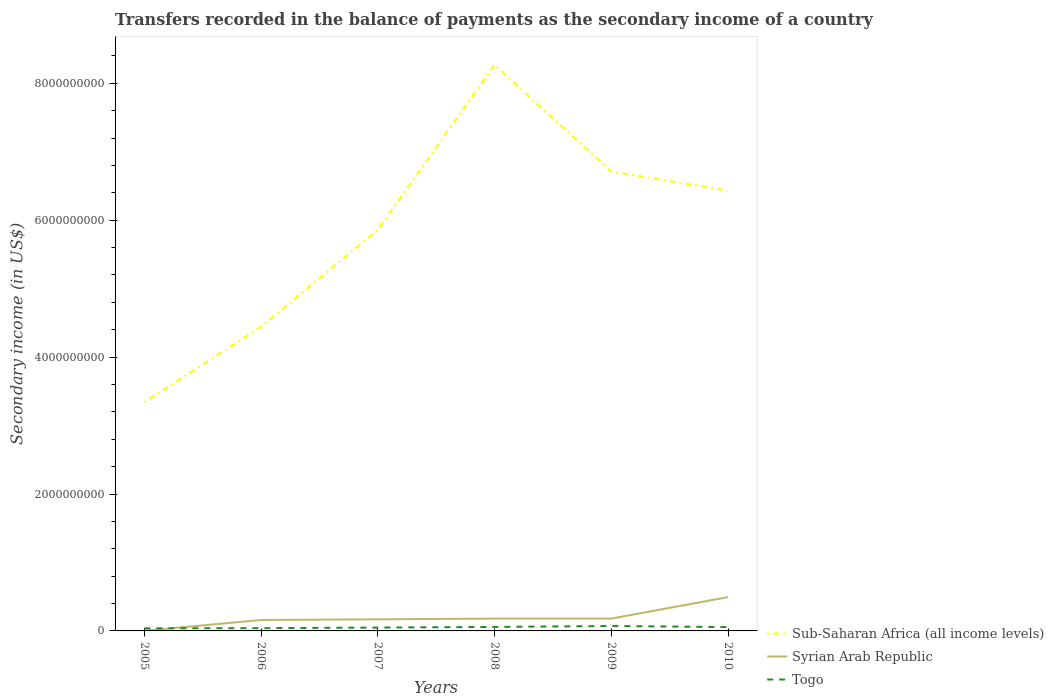How many different coloured lines are there?
Offer a very short reply. 3. Does the line corresponding to Sub-Saharan Africa (all income levels) intersect with the line corresponding to Togo?
Give a very brief answer. No. Across all years, what is the maximum secondary income of in Togo?
Keep it short and to the point. 3.81e+07. What is the total secondary income of in Togo in the graph?
Offer a very short reply. -2.27e+07. What is the difference between the highest and the second highest secondary income of in Sub-Saharan Africa (all income levels)?
Keep it short and to the point. 4.93e+09. Is the secondary income of in Syrian Arab Republic strictly greater than the secondary income of in Sub-Saharan Africa (all income levels) over the years?
Offer a terse response. Yes. How many lines are there?
Your response must be concise. 3. What is the difference between two consecutive major ticks on the Y-axis?
Provide a short and direct response. 2.00e+09. Does the graph contain grids?
Keep it short and to the point. No. Where does the legend appear in the graph?
Keep it short and to the point. Bottom right. How many legend labels are there?
Provide a short and direct response. 3. What is the title of the graph?
Provide a short and direct response. Transfers recorded in the balance of payments as the secondary income of a country. Does "Aruba" appear as one of the legend labels in the graph?
Provide a short and direct response. No. What is the label or title of the X-axis?
Your answer should be compact. Years. What is the label or title of the Y-axis?
Your response must be concise. Secondary income (in US$). What is the Secondary income (in US$) of Sub-Saharan Africa (all income levels) in 2005?
Offer a terse response. 3.34e+09. What is the Secondary income (in US$) of Togo in 2005?
Ensure brevity in your answer.  3.81e+07. What is the Secondary income (in US$) in Sub-Saharan Africa (all income levels) in 2006?
Offer a terse response. 4.45e+09. What is the Secondary income (in US$) in Syrian Arab Republic in 2006?
Ensure brevity in your answer.  1.60e+08. What is the Secondary income (in US$) of Togo in 2006?
Offer a very short reply. 4.04e+07. What is the Secondary income (in US$) in Sub-Saharan Africa (all income levels) in 2007?
Offer a terse response. 5.86e+09. What is the Secondary income (in US$) of Syrian Arab Republic in 2007?
Ensure brevity in your answer.  1.70e+08. What is the Secondary income (in US$) of Togo in 2007?
Your answer should be compact. 4.91e+07. What is the Secondary income (in US$) in Sub-Saharan Africa (all income levels) in 2008?
Provide a short and direct response. 8.27e+09. What is the Secondary income (in US$) of Syrian Arab Republic in 2008?
Ensure brevity in your answer.  1.80e+08. What is the Secondary income (in US$) of Togo in 2008?
Give a very brief answer. 5.82e+07. What is the Secondary income (in US$) in Sub-Saharan Africa (all income levels) in 2009?
Your response must be concise. 6.71e+09. What is the Secondary income (in US$) in Syrian Arab Republic in 2009?
Your answer should be very brief. 1.80e+08. What is the Secondary income (in US$) of Togo in 2009?
Your answer should be very brief. 7.19e+07. What is the Secondary income (in US$) in Sub-Saharan Africa (all income levels) in 2010?
Give a very brief answer. 6.43e+09. What is the Secondary income (in US$) in Syrian Arab Republic in 2010?
Provide a succinct answer. 4.94e+08. What is the Secondary income (in US$) in Togo in 2010?
Make the answer very short. 5.58e+07. Across all years, what is the maximum Secondary income (in US$) of Sub-Saharan Africa (all income levels)?
Give a very brief answer. 8.27e+09. Across all years, what is the maximum Secondary income (in US$) of Syrian Arab Republic?
Make the answer very short. 4.94e+08. Across all years, what is the maximum Secondary income (in US$) of Togo?
Offer a very short reply. 7.19e+07. Across all years, what is the minimum Secondary income (in US$) in Sub-Saharan Africa (all income levels)?
Offer a very short reply. 3.34e+09. Across all years, what is the minimum Secondary income (in US$) in Syrian Arab Republic?
Offer a terse response. 2.00e+06. Across all years, what is the minimum Secondary income (in US$) in Togo?
Provide a short and direct response. 3.81e+07. What is the total Secondary income (in US$) of Sub-Saharan Africa (all income levels) in the graph?
Your answer should be very brief. 3.51e+1. What is the total Secondary income (in US$) of Syrian Arab Republic in the graph?
Keep it short and to the point. 1.19e+09. What is the total Secondary income (in US$) of Togo in the graph?
Your answer should be compact. 3.13e+08. What is the difference between the Secondary income (in US$) of Sub-Saharan Africa (all income levels) in 2005 and that in 2006?
Keep it short and to the point. -1.11e+09. What is the difference between the Secondary income (in US$) in Syrian Arab Republic in 2005 and that in 2006?
Offer a very short reply. -1.58e+08. What is the difference between the Secondary income (in US$) in Togo in 2005 and that in 2006?
Keep it short and to the point. -2.28e+06. What is the difference between the Secondary income (in US$) in Sub-Saharan Africa (all income levels) in 2005 and that in 2007?
Provide a succinct answer. -2.52e+09. What is the difference between the Secondary income (in US$) of Syrian Arab Republic in 2005 and that in 2007?
Make the answer very short. -1.68e+08. What is the difference between the Secondary income (in US$) of Togo in 2005 and that in 2007?
Give a very brief answer. -1.10e+07. What is the difference between the Secondary income (in US$) of Sub-Saharan Africa (all income levels) in 2005 and that in 2008?
Ensure brevity in your answer.  -4.93e+09. What is the difference between the Secondary income (in US$) in Syrian Arab Republic in 2005 and that in 2008?
Your answer should be compact. -1.78e+08. What is the difference between the Secondary income (in US$) of Togo in 2005 and that in 2008?
Provide a succinct answer. -2.02e+07. What is the difference between the Secondary income (in US$) of Sub-Saharan Africa (all income levels) in 2005 and that in 2009?
Provide a short and direct response. -3.37e+09. What is the difference between the Secondary income (in US$) of Syrian Arab Republic in 2005 and that in 2009?
Provide a short and direct response. -1.78e+08. What is the difference between the Secondary income (in US$) of Togo in 2005 and that in 2009?
Your answer should be compact. -3.38e+07. What is the difference between the Secondary income (in US$) of Sub-Saharan Africa (all income levels) in 2005 and that in 2010?
Keep it short and to the point. -3.09e+09. What is the difference between the Secondary income (in US$) in Syrian Arab Republic in 2005 and that in 2010?
Provide a short and direct response. -4.92e+08. What is the difference between the Secondary income (in US$) in Togo in 2005 and that in 2010?
Provide a succinct answer. -1.77e+07. What is the difference between the Secondary income (in US$) of Sub-Saharan Africa (all income levels) in 2006 and that in 2007?
Provide a succinct answer. -1.42e+09. What is the difference between the Secondary income (in US$) in Syrian Arab Republic in 2006 and that in 2007?
Provide a succinct answer. -9.50e+06. What is the difference between the Secondary income (in US$) of Togo in 2006 and that in 2007?
Your response must be concise. -8.74e+06. What is the difference between the Secondary income (in US$) in Sub-Saharan Africa (all income levels) in 2006 and that in 2008?
Keep it short and to the point. -3.82e+09. What is the difference between the Secondary income (in US$) of Syrian Arab Republic in 2006 and that in 2008?
Give a very brief answer. -2.00e+07. What is the difference between the Secondary income (in US$) in Togo in 2006 and that in 2008?
Provide a short and direct response. -1.79e+07. What is the difference between the Secondary income (in US$) of Sub-Saharan Africa (all income levels) in 2006 and that in 2009?
Your answer should be compact. -2.27e+09. What is the difference between the Secondary income (in US$) in Syrian Arab Republic in 2006 and that in 2009?
Your answer should be compact. -2.00e+07. What is the difference between the Secondary income (in US$) of Togo in 2006 and that in 2009?
Provide a short and direct response. -3.15e+07. What is the difference between the Secondary income (in US$) of Sub-Saharan Africa (all income levels) in 2006 and that in 2010?
Offer a very short reply. -1.99e+09. What is the difference between the Secondary income (in US$) of Syrian Arab Republic in 2006 and that in 2010?
Your answer should be compact. -3.34e+08. What is the difference between the Secondary income (in US$) of Togo in 2006 and that in 2010?
Offer a terse response. -1.54e+07. What is the difference between the Secondary income (in US$) of Sub-Saharan Africa (all income levels) in 2007 and that in 2008?
Your answer should be very brief. -2.41e+09. What is the difference between the Secondary income (in US$) in Syrian Arab Republic in 2007 and that in 2008?
Offer a very short reply. -1.05e+07. What is the difference between the Secondary income (in US$) of Togo in 2007 and that in 2008?
Offer a very short reply. -9.14e+06. What is the difference between the Secondary income (in US$) of Sub-Saharan Africa (all income levels) in 2007 and that in 2009?
Offer a terse response. -8.49e+08. What is the difference between the Secondary income (in US$) in Syrian Arab Republic in 2007 and that in 2009?
Give a very brief answer. -1.05e+07. What is the difference between the Secondary income (in US$) of Togo in 2007 and that in 2009?
Offer a terse response. -2.27e+07. What is the difference between the Secondary income (in US$) in Sub-Saharan Africa (all income levels) in 2007 and that in 2010?
Keep it short and to the point. -5.71e+08. What is the difference between the Secondary income (in US$) of Syrian Arab Republic in 2007 and that in 2010?
Make the answer very short. -3.24e+08. What is the difference between the Secondary income (in US$) in Togo in 2007 and that in 2010?
Provide a short and direct response. -6.70e+06. What is the difference between the Secondary income (in US$) of Sub-Saharan Africa (all income levels) in 2008 and that in 2009?
Offer a very short reply. 1.56e+09. What is the difference between the Secondary income (in US$) in Togo in 2008 and that in 2009?
Your answer should be very brief. -1.36e+07. What is the difference between the Secondary income (in US$) in Sub-Saharan Africa (all income levels) in 2008 and that in 2010?
Keep it short and to the point. 1.84e+09. What is the difference between the Secondary income (in US$) in Syrian Arab Republic in 2008 and that in 2010?
Your answer should be compact. -3.14e+08. What is the difference between the Secondary income (in US$) in Togo in 2008 and that in 2010?
Keep it short and to the point. 2.44e+06. What is the difference between the Secondary income (in US$) of Sub-Saharan Africa (all income levels) in 2009 and that in 2010?
Provide a succinct answer. 2.78e+08. What is the difference between the Secondary income (in US$) of Syrian Arab Republic in 2009 and that in 2010?
Keep it short and to the point. -3.14e+08. What is the difference between the Secondary income (in US$) of Togo in 2009 and that in 2010?
Keep it short and to the point. 1.60e+07. What is the difference between the Secondary income (in US$) in Sub-Saharan Africa (all income levels) in 2005 and the Secondary income (in US$) in Syrian Arab Republic in 2006?
Provide a short and direct response. 3.18e+09. What is the difference between the Secondary income (in US$) of Sub-Saharan Africa (all income levels) in 2005 and the Secondary income (in US$) of Togo in 2006?
Your response must be concise. 3.30e+09. What is the difference between the Secondary income (in US$) in Syrian Arab Republic in 2005 and the Secondary income (in US$) in Togo in 2006?
Give a very brief answer. -3.84e+07. What is the difference between the Secondary income (in US$) in Sub-Saharan Africa (all income levels) in 2005 and the Secondary income (in US$) in Syrian Arab Republic in 2007?
Offer a very short reply. 3.17e+09. What is the difference between the Secondary income (in US$) of Sub-Saharan Africa (all income levels) in 2005 and the Secondary income (in US$) of Togo in 2007?
Offer a very short reply. 3.29e+09. What is the difference between the Secondary income (in US$) in Syrian Arab Republic in 2005 and the Secondary income (in US$) in Togo in 2007?
Offer a very short reply. -4.71e+07. What is the difference between the Secondary income (in US$) of Sub-Saharan Africa (all income levels) in 2005 and the Secondary income (in US$) of Syrian Arab Republic in 2008?
Give a very brief answer. 3.16e+09. What is the difference between the Secondary income (in US$) in Sub-Saharan Africa (all income levels) in 2005 and the Secondary income (in US$) in Togo in 2008?
Ensure brevity in your answer.  3.28e+09. What is the difference between the Secondary income (in US$) in Syrian Arab Republic in 2005 and the Secondary income (in US$) in Togo in 2008?
Provide a short and direct response. -5.62e+07. What is the difference between the Secondary income (in US$) of Sub-Saharan Africa (all income levels) in 2005 and the Secondary income (in US$) of Syrian Arab Republic in 2009?
Your answer should be compact. 3.16e+09. What is the difference between the Secondary income (in US$) of Sub-Saharan Africa (all income levels) in 2005 and the Secondary income (in US$) of Togo in 2009?
Your answer should be compact. 3.27e+09. What is the difference between the Secondary income (in US$) of Syrian Arab Republic in 2005 and the Secondary income (in US$) of Togo in 2009?
Ensure brevity in your answer.  -6.99e+07. What is the difference between the Secondary income (in US$) of Sub-Saharan Africa (all income levels) in 2005 and the Secondary income (in US$) of Syrian Arab Republic in 2010?
Ensure brevity in your answer.  2.85e+09. What is the difference between the Secondary income (in US$) in Sub-Saharan Africa (all income levels) in 2005 and the Secondary income (in US$) in Togo in 2010?
Your answer should be very brief. 3.28e+09. What is the difference between the Secondary income (in US$) in Syrian Arab Republic in 2005 and the Secondary income (in US$) in Togo in 2010?
Your response must be concise. -5.38e+07. What is the difference between the Secondary income (in US$) of Sub-Saharan Africa (all income levels) in 2006 and the Secondary income (in US$) of Syrian Arab Republic in 2007?
Ensure brevity in your answer.  4.28e+09. What is the difference between the Secondary income (in US$) of Sub-Saharan Africa (all income levels) in 2006 and the Secondary income (in US$) of Togo in 2007?
Your response must be concise. 4.40e+09. What is the difference between the Secondary income (in US$) in Syrian Arab Republic in 2006 and the Secondary income (in US$) in Togo in 2007?
Make the answer very short. 1.11e+08. What is the difference between the Secondary income (in US$) of Sub-Saharan Africa (all income levels) in 2006 and the Secondary income (in US$) of Syrian Arab Republic in 2008?
Your response must be concise. 4.27e+09. What is the difference between the Secondary income (in US$) of Sub-Saharan Africa (all income levels) in 2006 and the Secondary income (in US$) of Togo in 2008?
Offer a terse response. 4.39e+09. What is the difference between the Secondary income (in US$) in Syrian Arab Republic in 2006 and the Secondary income (in US$) in Togo in 2008?
Your answer should be compact. 1.02e+08. What is the difference between the Secondary income (in US$) in Sub-Saharan Africa (all income levels) in 2006 and the Secondary income (in US$) in Syrian Arab Republic in 2009?
Ensure brevity in your answer.  4.27e+09. What is the difference between the Secondary income (in US$) of Sub-Saharan Africa (all income levels) in 2006 and the Secondary income (in US$) of Togo in 2009?
Make the answer very short. 4.37e+09. What is the difference between the Secondary income (in US$) in Syrian Arab Republic in 2006 and the Secondary income (in US$) in Togo in 2009?
Provide a short and direct response. 8.81e+07. What is the difference between the Secondary income (in US$) in Sub-Saharan Africa (all income levels) in 2006 and the Secondary income (in US$) in Syrian Arab Republic in 2010?
Provide a short and direct response. 3.95e+09. What is the difference between the Secondary income (in US$) in Sub-Saharan Africa (all income levels) in 2006 and the Secondary income (in US$) in Togo in 2010?
Your answer should be very brief. 4.39e+09. What is the difference between the Secondary income (in US$) of Syrian Arab Republic in 2006 and the Secondary income (in US$) of Togo in 2010?
Provide a succinct answer. 1.04e+08. What is the difference between the Secondary income (in US$) in Sub-Saharan Africa (all income levels) in 2007 and the Secondary income (in US$) in Syrian Arab Republic in 2008?
Provide a short and direct response. 5.68e+09. What is the difference between the Secondary income (in US$) in Sub-Saharan Africa (all income levels) in 2007 and the Secondary income (in US$) in Togo in 2008?
Ensure brevity in your answer.  5.80e+09. What is the difference between the Secondary income (in US$) of Syrian Arab Republic in 2007 and the Secondary income (in US$) of Togo in 2008?
Offer a very short reply. 1.11e+08. What is the difference between the Secondary income (in US$) of Sub-Saharan Africa (all income levels) in 2007 and the Secondary income (in US$) of Syrian Arab Republic in 2009?
Provide a short and direct response. 5.68e+09. What is the difference between the Secondary income (in US$) in Sub-Saharan Africa (all income levels) in 2007 and the Secondary income (in US$) in Togo in 2009?
Your answer should be very brief. 5.79e+09. What is the difference between the Secondary income (in US$) of Syrian Arab Republic in 2007 and the Secondary income (in US$) of Togo in 2009?
Offer a terse response. 9.76e+07. What is the difference between the Secondary income (in US$) in Sub-Saharan Africa (all income levels) in 2007 and the Secondary income (in US$) in Syrian Arab Republic in 2010?
Offer a very short reply. 5.37e+09. What is the difference between the Secondary income (in US$) in Sub-Saharan Africa (all income levels) in 2007 and the Secondary income (in US$) in Togo in 2010?
Make the answer very short. 5.81e+09. What is the difference between the Secondary income (in US$) of Syrian Arab Republic in 2007 and the Secondary income (in US$) of Togo in 2010?
Your answer should be compact. 1.14e+08. What is the difference between the Secondary income (in US$) of Sub-Saharan Africa (all income levels) in 2008 and the Secondary income (in US$) of Syrian Arab Republic in 2009?
Provide a short and direct response. 8.09e+09. What is the difference between the Secondary income (in US$) in Sub-Saharan Africa (all income levels) in 2008 and the Secondary income (in US$) in Togo in 2009?
Offer a very short reply. 8.20e+09. What is the difference between the Secondary income (in US$) of Syrian Arab Republic in 2008 and the Secondary income (in US$) of Togo in 2009?
Your answer should be very brief. 1.08e+08. What is the difference between the Secondary income (in US$) in Sub-Saharan Africa (all income levels) in 2008 and the Secondary income (in US$) in Syrian Arab Republic in 2010?
Provide a succinct answer. 7.78e+09. What is the difference between the Secondary income (in US$) in Sub-Saharan Africa (all income levels) in 2008 and the Secondary income (in US$) in Togo in 2010?
Your answer should be compact. 8.21e+09. What is the difference between the Secondary income (in US$) of Syrian Arab Republic in 2008 and the Secondary income (in US$) of Togo in 2010?
Ensure brevity in your answer.  1.24e+08. What is the difference between the Secondary income (in US$) in Sub-Saharan Africa (all income levels) in 2009 and the Secondary income (in US$) in Syrian Arab Republic in 2010?
Your answer should be compact. 6.22e+09. What is the difference between the Secondary income (in US$) of Sub-Saharan Africa (all income levels) in 2009 and the Secondary income (in US$) of Togo in 2010?
Offer a very short reply. 6.66e+09. What is the difference between the Secondary income (in US$) of Syrian Arab Republic in 2009 and the Secondary income (in US$) of Togo in 2010?
Offer a very short reply. 1.24e+08. What is the average Secondary income (in US$) in Sub-Saharan Africa (all income levels) per year?
Make the answer very short. 5.84e+09. What is the average Secondary income (in US$) in Syrian Arab Republic per year?
Your answer should be very brief. 1.98e+08. What is the average Secondary income (in US$) in Togo per year?
Keep it short and to the point. 5.22e+07. In the year 2005, what is the difference between the Secondary income (in US$) of Sub-Saharan Africa (all income levels) and Secondary income (in US$) of Syrian Arab Republic?
Your answer should be compact. 3.34e+09. In the year 2005, what is the difference between the Secondary income (in US$) in Sub-Saharan Africa (all income levels) and Secondary income (in US$) in Togo?
Your answer should be very brief. 3.30e+09. In the year 2005, what is the difference between the Secondary income (in US$) in Syrian Arab Republic and Secondary income (in US$) in Togo?
Offer a terse response. -3.61e+07. In the year 2006, what is the difference between the Secondary income (in US$) in Sub-Saharan Africa (all income levels) and Secondary income (in US$) in Syrian Arab Republic?
Ensure brevity in your answer.  4.29e+09. In the year 2006, what is the difference between the Secondary income (in US$) in Sub-Saharan Africa (all income levels) and Secondary income (in US$) in Togo?
Give a very brief answer. 4.40e+09. In the year 2006, what is the difference between the Secondary income (in US$) in Syrian Arab Republic and Secondary income (in US$) in Togo?
Your answer should be very brief. 1.20e+08. In the year 2007, what is the difference between the Secondary income (in US$) of Sub-Saharan Africa (all income levels) and Secondary income (in US$) of Syrian Arab Republic?
Offer a terse response. 5.69e+09. In the year 2007, what is the difference between the Secondary income (in US$) in Sub-Saharan Africa (all income levels) and Secondary income (in US$) in Togo?
Keep it short and to the point. 5.81e+09. In the year 2007, what is the difference between the Secondary income (in US$) of Syrian Arab Republic and Secondary income (in US$) of Togo?
Provide a succinct answer. 1.20e+08. In the year 2008, what is the difference between the Secondary income (in US$) in Sub-Saharan Africa (all income levels) and Secondary income (in US$) in Syrian Arab Republic?
Your answer should be very brief. 8.09e+09. In the year 2008, what is the difference between the Secondary income (in US$) of Sub-Saharan Africa (all income levels) and Secondary income (in US$) of Togo?
Keep it short and to the point. 8.21e+09. In the year 2008, what is the difference between the Secondary income (in US$) in Syrian Arab Republic and Secondary income (in US$) in Togo?
Your answer should be very brief. 1.22e+08. In the year 2009, what is the difference between the Secondary income (in US$) of Sub-Saharan Africa (all income levels) and Secondary income (in US$) of Syrian Arab Republic?
Ensure brevity in your answer.  6.53e+09. In the year 2009, what is the difference between the Secondary income (in US$) of Sub-Saharan Africa (all income levels) and Secondary income (in US$) of Togo?
Ensure brevity in your answer.  6.64e+09. In the year 2009, what is the difference between the Secondary income (in US$) of Syrian Arab Republic and Secondary income (in US$) of Togo?
Offer a terse response. 1.08e+08. In the year 2010, what is the difference between the Secondary income (in US$) in Sub-Saharan Africa (all income levels) and Secondary income (in US$) in Syrian Arab Republic?
Provide a succinct answer. 5.94e+09. In the year 2010, what is the difference between the Secondary income (in US$) in Sub-Saharan Africa (all income levels) and Secondary income (in US$) in Togo?
Offer a very short reply. 6.38e+09. In the year 2010, what is the difference between the Secondary income (in US$) of Syrian Arab Republic and Secondary income (in US$) of Togo?
Provide a succinct answer. 4.38e+08. What is the ratio of the Secondary income (in US$) in Sub-Saharan Africa (all income levels) in 2005 to that in 2006?
Give a very brief answer. 0.75. What is the ratio of the Secondary income (in US$) in Syrian Arab Republic in 2005 to that in 2006?
Offer a very short reply. 0.01. What is the ratio of the Secondary income (in US$) in Togo in 2005 to that in 2006?
Ensure brevity in your answer.  0.94. What is the ratio of the Secondary income (in US$) of Sub-Saharan Africa (all income levels) in 2005 to that in 2007?
Offer a very short reply. 0.57. What is the ratio of the Secondary income (in US$) of Syrian Arab Republic in 2005 to that in 2007?
Provide a short and direct response. 0.01. What is the ratio of the Secondary income (in US$) in Togo in 2005 to that in 2007?
Ensure brevity in your answer.  0.78. What is the ratio of the Secondary income (in US$) in Sub-Saharan Africa (all income levels) in 2005 to that in 2008?
Your response must be concise. 0.4. What is the ratio of the Secondary income (in US$) of Syrian Arab Republic in 2005 to that in 2008?
Make the answer very short. 0.01. What is the ratio of the Secondary income (in US$) in Togo in 2005 to that in 2008?
Provide a succinct answer. 0.65. What is the ratio of the Secondary income (in US$) in Sub-Saharan Africa (all income levels) in 2005 to that in 2009?
Provide a succinct answer. 0.5. What is the ratio of the Secondary income (in US$) of Syrian Arab Republic in 2005 to that in 2009?
Ensure brevity in your answer.  0.01. What is the ratio of the Secondary income (in US$) in Togo in 2005 to that in 2009?
Make the answer very short. 0.53. What is the ratio of the Secondary income (in US$) of Sub-Saharan Africa (all income levels) in 2005 to that in 2010?
Make the answer very short. 0.52. What is the ratio of the Secondary income (in US$) in Syrian Arab Republic in 2005 to that in 2010?
Your answer should be compact. 0. What is the ratio of the Secondary income (in US$) of Togo in 2005 to that in 2010?
Your answer should be very brief. 0.68. What is the ratio of the Secondary income (in US$) in Sub-Saharan Africa (all income levels) in 2006 to that in 2007?
Keep it short and to the point. 0.76. What is the ratio of the Secondary income (in US$) in Syrian Arab Republic in 2006 to that in 2007?
Keep it short and to the point. 0.94. What is the ratio of the Secondary income (in US$) of Togo in 2006 to that in 2007?
Provide a succinct answer. 0.82. What is the ratio of the Secondary income (in US$) of Sub-Saharan Africa (all income levels) in 2006 to that in 2008?
Offer a very short reply. 0.54. What is the ratio of the Secondary income (in US$) in Syrian Arab Republic in 2006 to that in 2008?
Provide a succinct answer. 0.89. What is the ratio of the Secondary income (in US$) of Togo in 2006 to that in 2008?
Provide a succinct answer. 0.69. What is the ratio of the Secondary income (in US$) in Sub-Saharan Africa (all income levels) in 2006 to that in 2009?
Offer a very short reply. 0.66. What is the ratio of the Secondary income (in US$) of Syrian Arab Republic in 2006 to that in 2009?
Your answer should be very brief. 0.89. What is the ratio of the Secondary income (in US$) of Togo in 2006 to that in 2009?
Offer a terse response. 0.56. What is the ratio of the Secondary income (in US$) of Sub-Saharan Africa (all income levels) in 2006 to that in 2010?
Your response must be concise. 0.69. What is the ratio of the Secondary income (in US$) of Syrian Arab Republic in 2006 to that in 2010?
Offer a terse response. 0.32. What is the ratio of the Secondary income (in US$) in Togo in 2006 to that in 2010?
Ensure brevity in your answer.  0.72. What is the ratio of the Secondary income (in US$) of Sub-Saharan Africa (all income levels) in 2007 to that in 2008?
Provide a succinct answer. 0.71. What is the ratio of the Secondary income (in US$) of Syrian Arab Republic in 2007 to that in 2008?
Offer a terse response. 0.94. What is the ratio of the Secondary income (in US$) in Togo in 2007 to that in 2008?
Provide a short and direct response. 0.84. What is the ratio of the Secondary income (in US$) of Sub-Saharan Africa (all income levels) in 2007 to that in 2009?
Your answer should be very brief. 0.87. What is the ratio of the Secondary income (in US$) of Syrian Arab Republic in 2007 to that in 2009?
Offer a terse response. 0.94. What is the ratio of the Secondary income (in US$) of Togo in 2007 to that in 2009?
Give a very brief answer. 0.68. What is the ratio of the Secondary income (in US$) of Sub-Saharan Africa (all income levels) in 2007 to that in 2010?
Provide a succinct answer. 0.91. What is the ratio of the Secondary income (in US$) in Syrian Arab Republic in 2007 to that in 2010?
Keep it short and to the point. 0.34. What is the ratio of the Secondary income (in US$) in Togo in 2007 to that in 2010?
Offer a terse response. 0.88. What is the ratio of the Secondary income (in US$) of Sub-Saharan Africa (all income levels) in 2008 to that in 2009?
Keep it short and to the point. 1.23. What is the ratio of the Secondary income (in US$) in Togo in 2008 to that in 2009?
Provide a short and direct response. 0.81. What is the ratio of the Secondary income (in US$) of Sub-Saharan Africa (all income levels) in 2008 to that in 2010?
Provide a short and direct response. 1.29. What is the ratio of the Secondary income (in US$) of Syrian Arab Republic in 2008 to that in 2010?
Provide a succinct answer. 0.36. What is the ratio of the Secondary income (in US$) in Togo in 2008 to that in 2010?
Make the answer very short. 1.04. What is the ratio of the Secondary income (in US$) in Sub-Saharan Africa (all income levels) in 2009 to that in 2010?
Ensure brevity in your answer.  1.04. What is the ratio of the Secondary income (in US$) in Syrian Arab Republic in 2009 to that in 2010?
Offer a terse response. 0.36. What is the ratio of the Secondary income (in US$) in Togo in 2009 to that in 2010?
Give a very brief answer. 1.29. What is the difference between the highest and the second highest Secondary income (in US$) in Sub-Saharan Africa (all income levels)?
Your answer should be very brief. 1.56e+09. What is the difference between the highest and the second highest Secondary income (in US$) of Syrian Arab Republic?
Offer a terse response. 3.14e+08. What is the difference between the highest and the second highest Secondary income (in US$) of Togo?
Provide a short and direct response. 1.36e+07. What is the difference between the highest and the lowest Secondary income (in US$) of Sub-Saharan Africa (all income levels)?
Your answer should be compact. 4.93e+09. What is the difference between the highest and the lowest Secondary income (in US$) of Syrian Arab Republic?
Offer a terse response. 4.92e+08. What is the difference between the highest and the lowest Secondary income (in US$) of Togo?
Ensure brevity in your answer.  3.38e+07. 